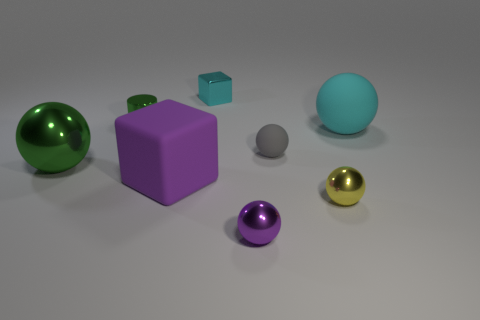Are there any other things that are the same shape as the tiny green object?
Make the answer very short. No. Does the tiny metal cylinder have the same color as the large metal thing?
Make the answer very short. Yes. What number of large things are there?
Give a very brief answer. 3. Is the number of purple balls that are to the left of the tiny green metallic object less than the number of tiny purple metallic things that are to the right of the big matte cube?
Make the answer very short. Yes. Are there fewer tiny shiny things in front of the small yellow sphere than big spheres?
Make the answer very short. Yes. What is the material of the large ball left of the large thing that is to the right of the cyan thing that is behind the large cyan object?
Keep it short and to the point. Metal. How many things are either big matte objects that are to the right of the small cube or cyan objects that are right of the tiny cyan thing?
Provide a succinct answer. 1. What material is the other object that is the same shape as the purple matte object?
Your answer should be very brief. Metal. What number of matte objects are large gray objects or cyan blocks?
Your response must be concise. 0. The tiny cyan thing that is the same material as the tiny purple ball is what shape?
Provide a short and direct response. Cube. 